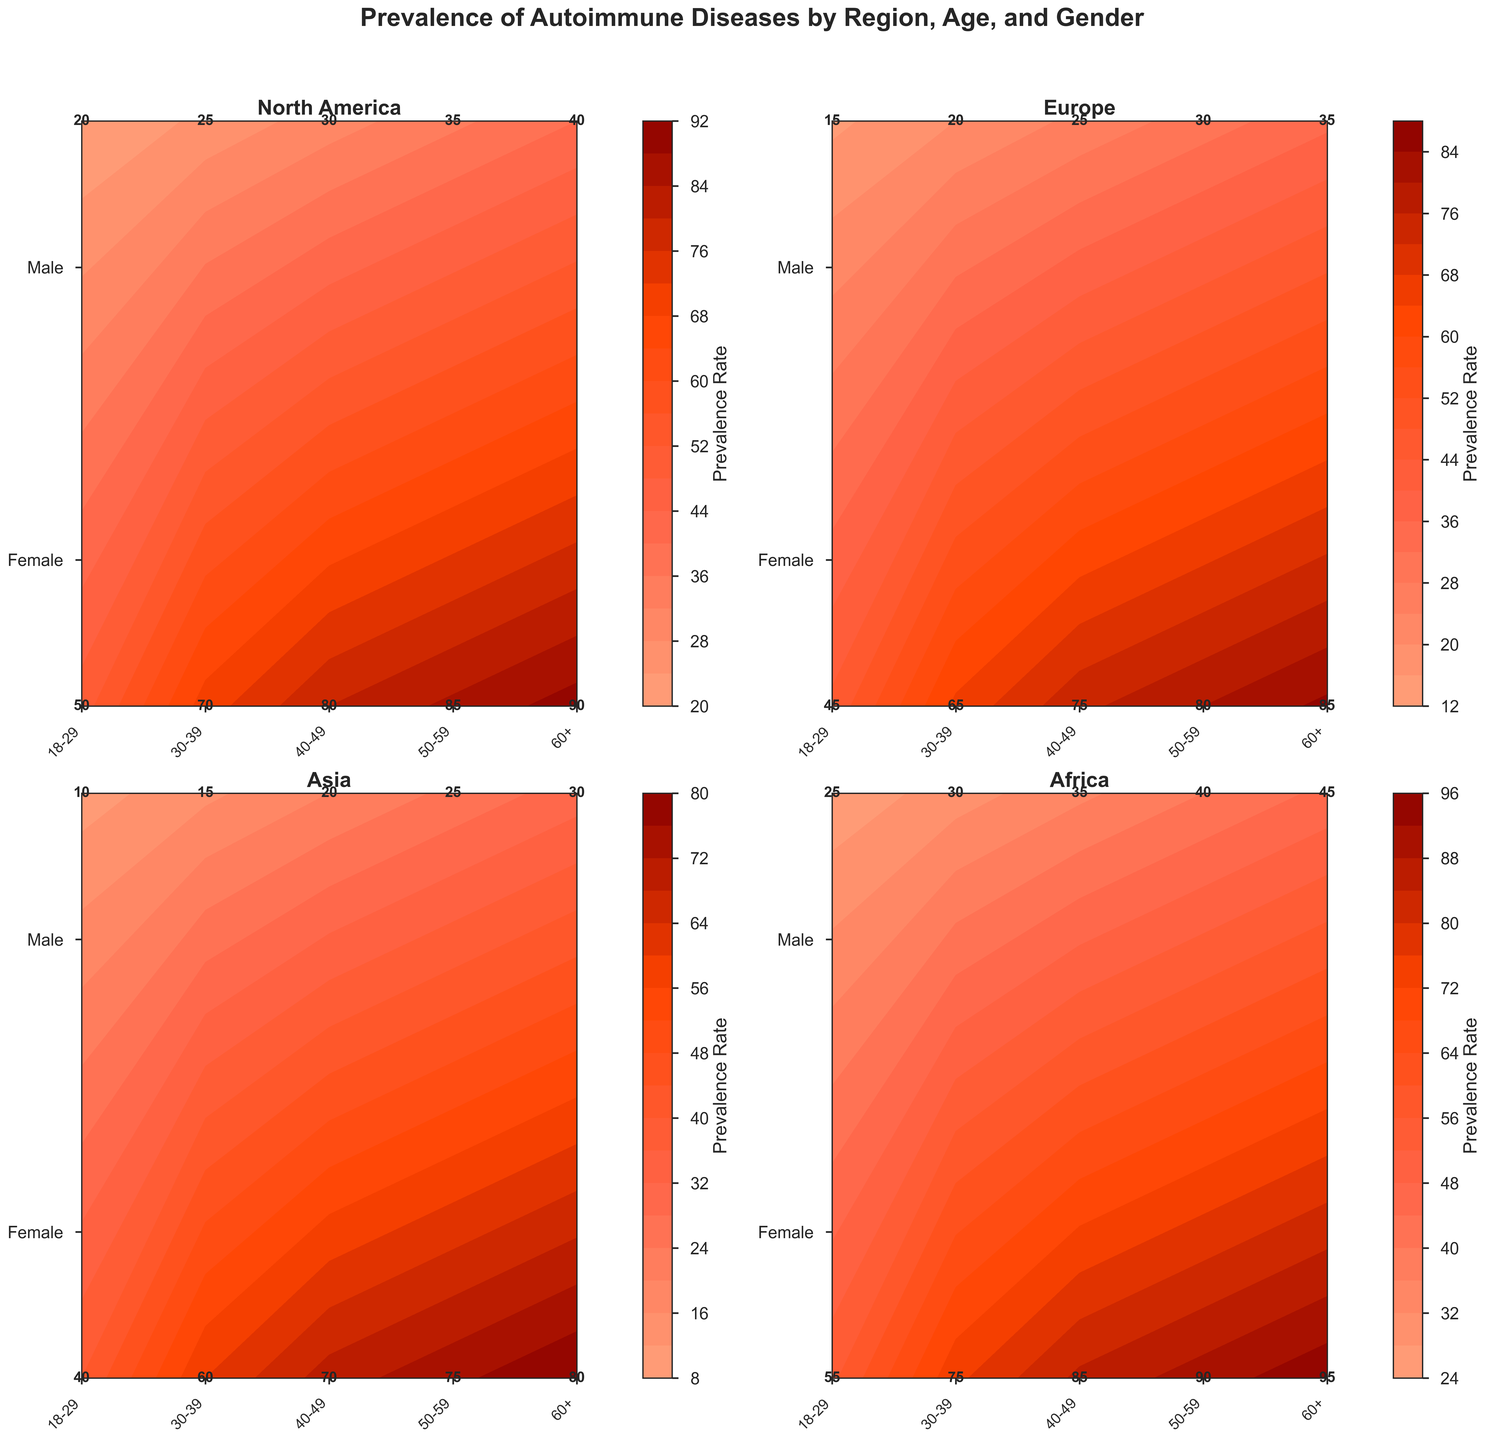What is the title of the figure? The title is usually displayed at the top of the figure. In this case, it is mentioned in the `fig.suptitle()` function. The title is "Prevalence of Autoimmune Diseases by Region, Age, and Gender"
Answer: Prevalence of Autoimmune Diseases by Region, Age, and Gender Which geographical region shows the highest prevalence rate for females aged 60+? To answer this, look for the highest number in the '60+' column for females in each subplot. Africa shows 95, which is the highest among the regions.
Answer: Africa In which region do males aged 18-29 have the lowest prevalence rate? Examine the prevalence rate for males aged 18-29 in each region's subplot. Asia has the lowest value at 10.
Answer: Asia How does the prevalence rate for females aged 30-39 in North America compare to the same age group in Africa? Check the prevalence rates for females aged 30-39 in North America (70) and Africa (75). Comparing these values, Africa has a higher rate.
Answer: Higher in Africa What is the overall trend in prevalence rates for females across different age groups in Europe? Follow the contour lines or labeled values in Europe's subplot for females from 18-29 to 60+. The trend shows a gradual increase in prevalence rates as age increases, starting from 45 up to 85.
Answer: Gradually increasing Compare the prevalence rates for males aged 50-59 across all regions. Which region has the highest rate? Look at the rates for males aged 50-59 in all subplots. North America and Africa both show 40, but Africa has a higher rate overall for other demographics, contributing to a 45 in males aged 60+.
Answer: Africa Is there any region where the prevalence rates for females and males aged 40-49 are equal? Examine the prevalence rates for both genders aged 40-49 in all subplots. No regions have equal rates; the closest is Asia with 70 (female) and 20 (male).
Answer: No What is the average prevalence rate for females aged 18-29 across all regions? Sum the prevalence rates for females aged 18-29 in all regions: (50 + 45 + 40 + 55) = 190, and divide by 4 regions. The average is 190 / 4 = 47.5
Answer: 47.5 Which region has the most noticeable gender disparity in prevalence rates for the age group 18-29? Compare the differences between prevalence rates for females and males aged 18-29 in all regions. North America shows the highest disparity with 50 (female) and 20 (male), resulting in a difference of 30.
Answer: North America 